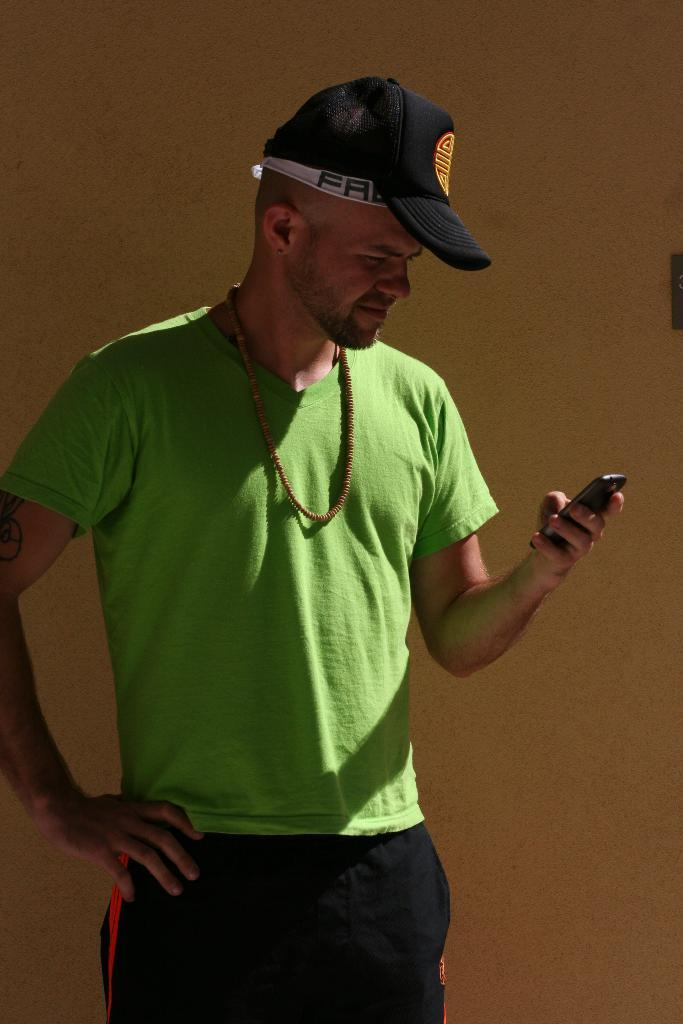Who is present in the image? There is a man in the image. What is the man doing in the image? The man is standing in the image. What object is the man holding in the image? The man is holding a mobile phone in the image. What can be seen in the background of the image? There is a wall in the background of the image. What type of rice is being cooked in the image? There is no rice present in the image; it features a man standing and holding a mobile phone. How many pigs are visible in the image? There are no pigs present in the image. 